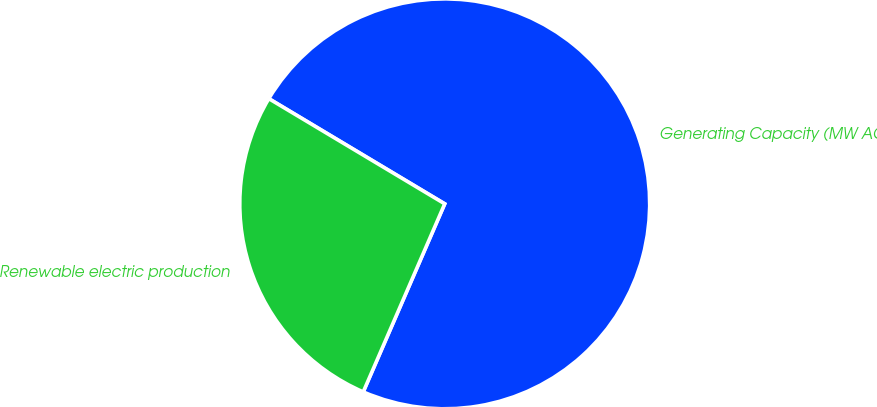<chart> <loc_0><loc_0><loc_500><loc_500><pie_chart><fcel>Generating Capacity (MW AC)<fcel>Renewable electric production<nl><fcel>72.93%<fcel>27.07%<nl></chart> 